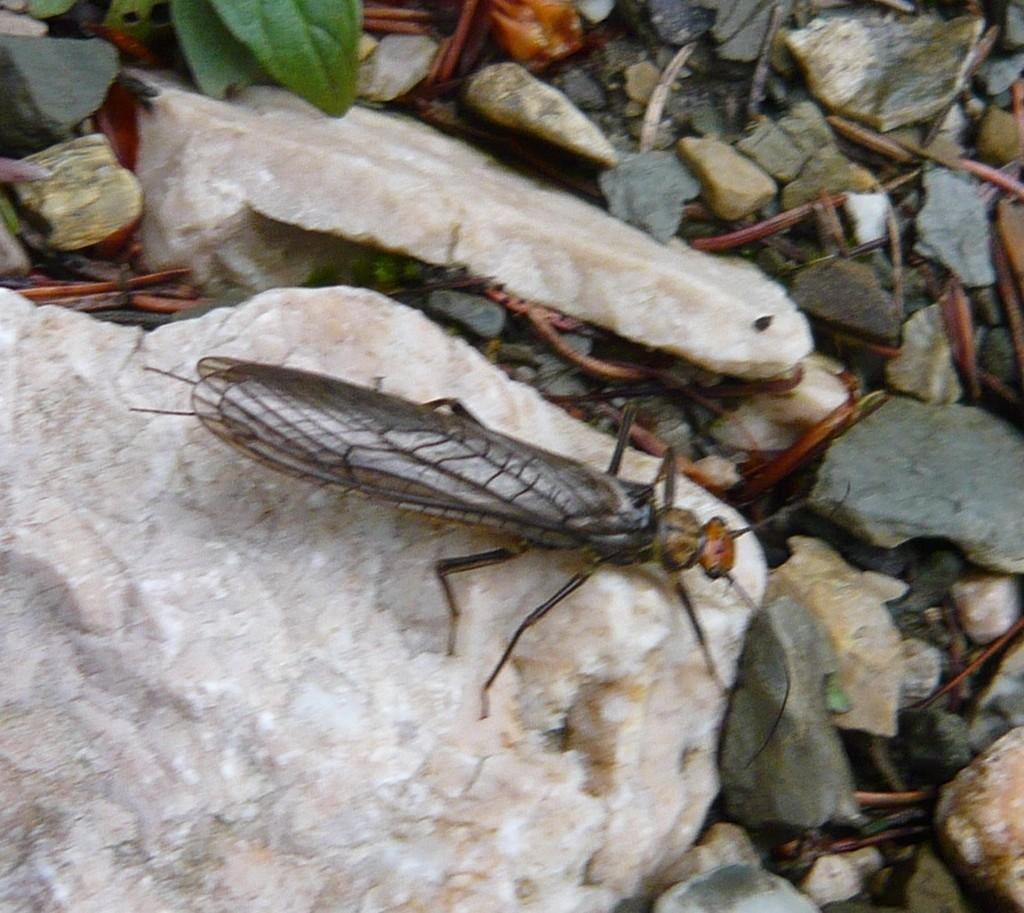What type of creature can be seen in the image? There is an insect in the image. What other objects are present in the image besides the insect? There are stones and leaves in the image. How many pigs are visible in the image? There are no pigs present in the image. What type of design can be seen on the leaves in the image? The provided facts do not mention any specific design on the leaves, so we cannot answer this question. 